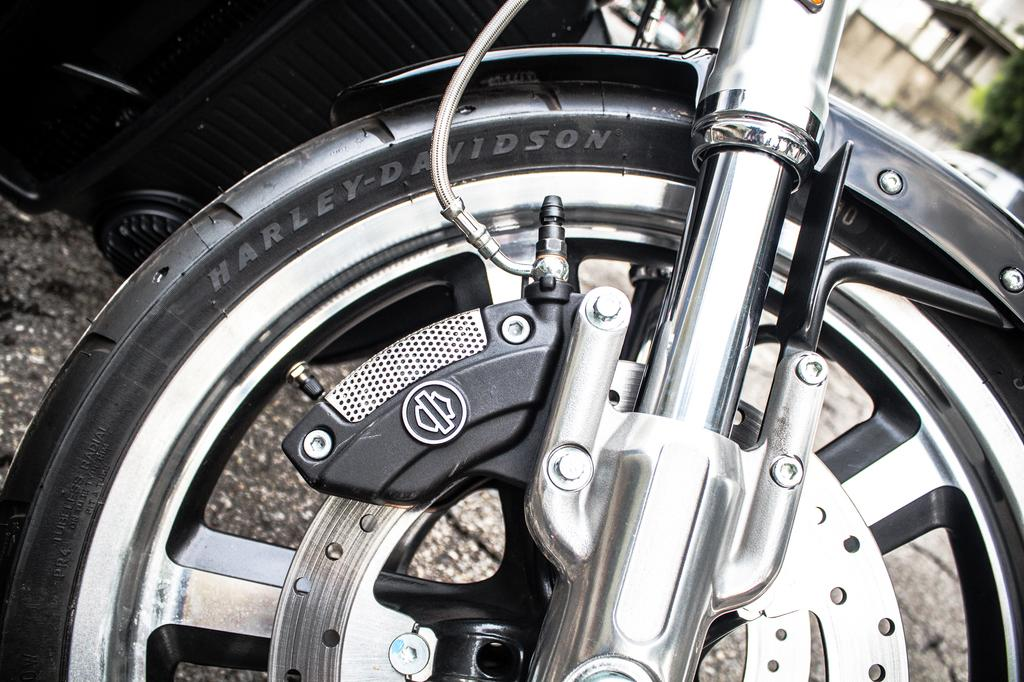What can be seen in the image that is related to a bike? There is a wheel of a bike in the image. What is written or printed on the bike wheel? There is text on the bike wheel. What object is located beside the bike? There is an object beside the bike. What can be seen in the distance in the image? There is a building and a tree in the background of the image. How many cracks can be seen on the bike wheel in the image? There is no mention of cracks on the bike wheel in the image, so we cannot determine the number of cracks. Are there any deer visible in the image? There is no mention of deer in the image, so we cannot determine if any are present. 